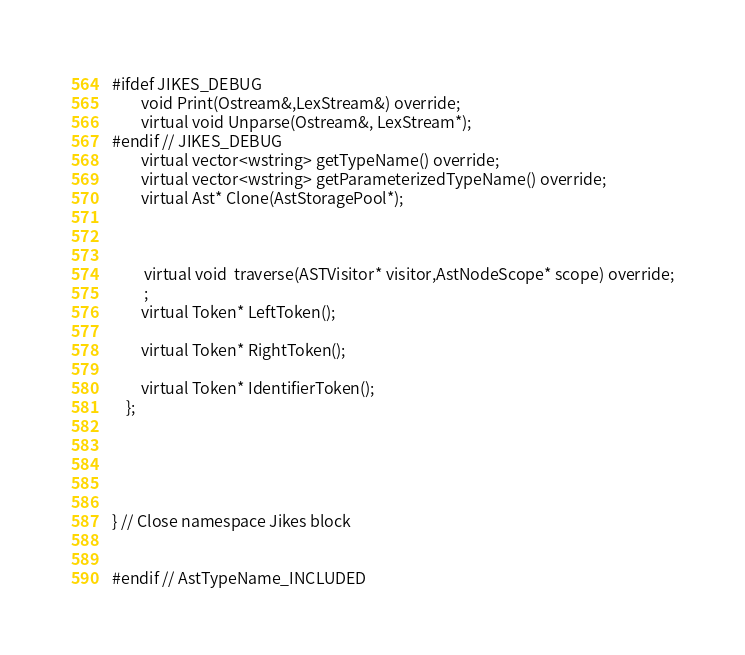Convert code to text. <code><loc_0><loc_0><loc_500><loc_500><_C_>
#ifdef JIKES_DEBUG
		void Print(Ostream&,LexStream&) override;
		virtual void Unparse(Ostream&, LexStream*);
#endif // JIKES_DEBUG
		virtual vector<wstring> getTypeName() override;
		virtual vector<wstring> getParameterizedTypeName() override;
		virtual Ast* Clone(AstStoragePool*);
		
		

		 virtual void  traverse(ASTVisitor* visitor,AstNodeScope* scope) override;
		 ;
		virtual Token* LeftToken();

		virtual Token* RightToken();

		virtual Token* IdentifierToken();
	};





} // Close namespace Jikes block


#endif // AstTypeName_INCLUDED
</code> 